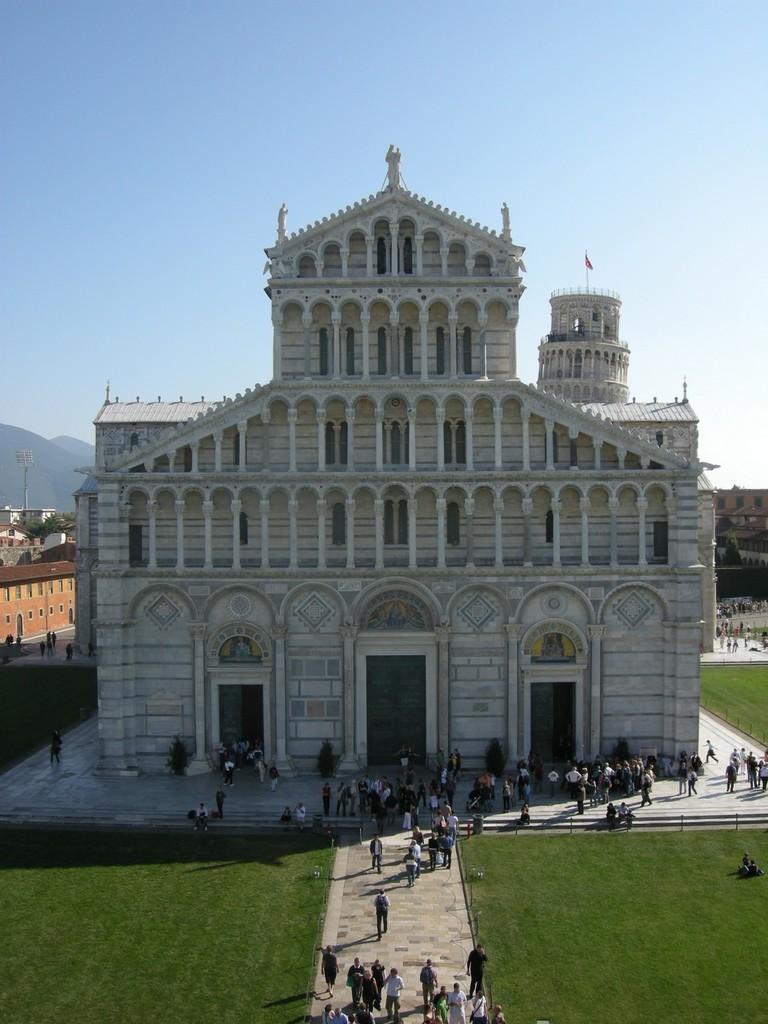Could you give a brief overview of what you see in this image? In this image in the front there are persons, there's grass on the ground. In the background there are buildings, persons and there are mountains, at the top we can see sky. 